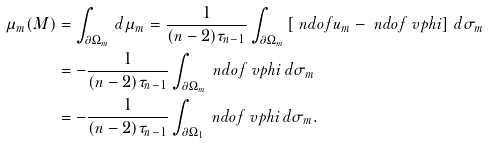<formula> <loc_0><loc_0><loc_500><loc_500>\mu _ { m } ( M ) & = \int _ { \partial \Omega _ { m } } \, d \mu _ { m } = \frac { 1 } { ( n - 2 ) \tau _ { n - 1 } } \int _ { \partial \Omega _ { m } } \left [ \ n d o f { u _ { m } } - \ n d o f { \ v p h i } \right ] \, d \sigma _ { m } \\ & = - \frac { 1 } { ( n - 2 ) \tau _ { n - 1 } } \int _ { \partial \Omega _ { m } } \ n d o f { \ v p h i } \, d \sigma _ { m } \\ & = - \frac { 1 } { ( n - 2 ) \tau _ { n - 1 } } \int _ { \partial \Omega _ { 1 } } \ n d o f { \ v p h i } \, d \sigma _ { m } .</formula> 